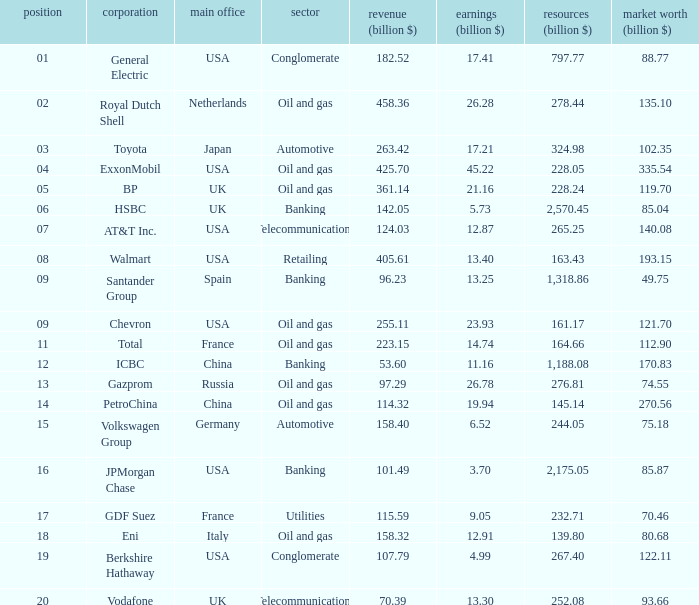Name the highest Profits (billion $) which has a Company of walmart? 13.4. 